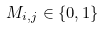Convert formula to latex. <formula><loc_0><loc_0><loc_500><loc_500>M _ { i , j } \in \{ 0 , 1 \}</formula> 